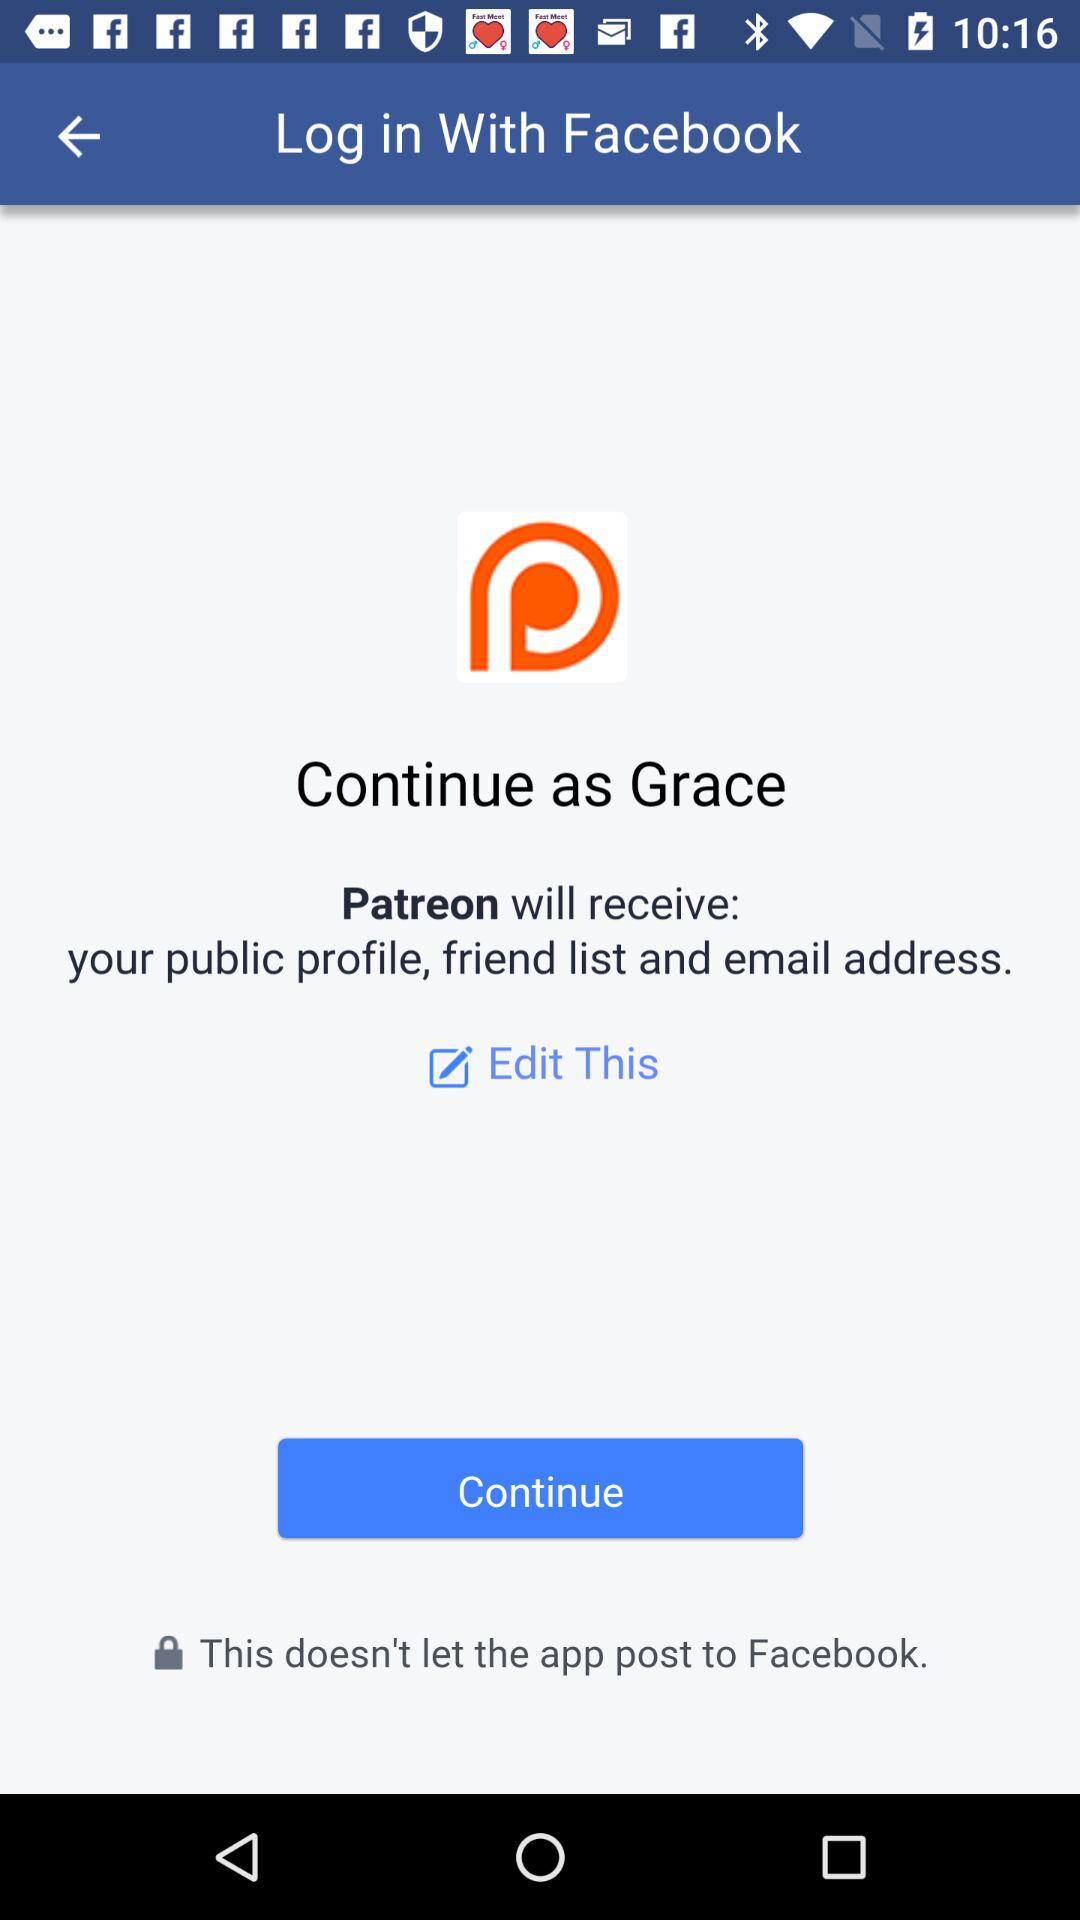What application is asking for permission? The application asking for permission is "Patreon". 